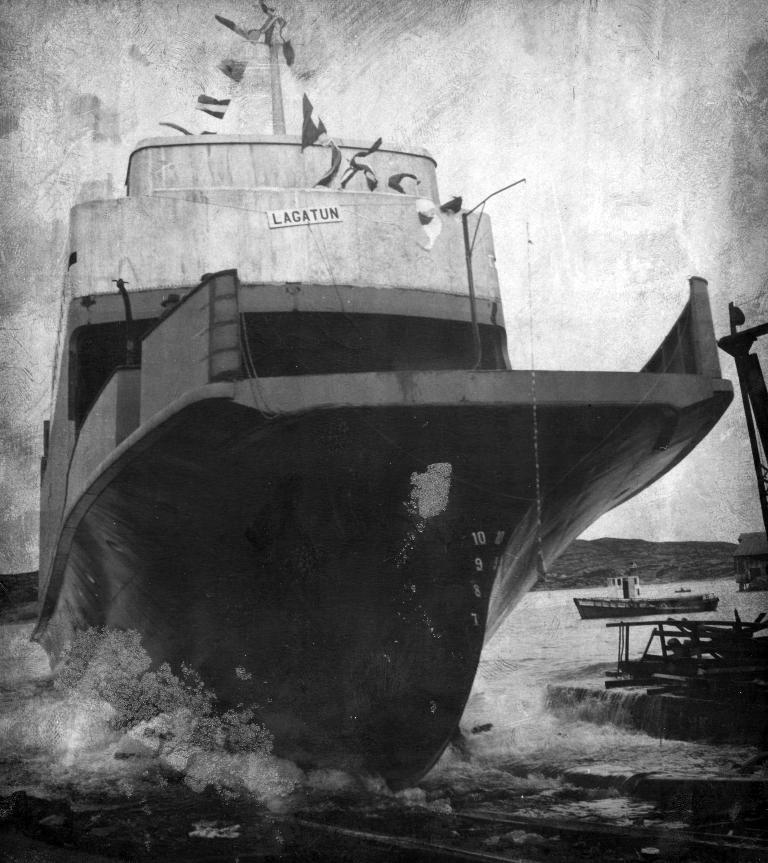What type of vehicle is in the image? There is a cargo ship in the image. Where is the cargo ship located? The cargo ship is on the water. What else can be seen on the right side of the image? There are other boards visible on the right side of the image. What is visible in the background of the image? There is a mountain in the background of the image. What is visible at the top of the image? The sky is visible at the top of the image. Where is the zoo located in the image? There is no zoo present in the image; it features a cargo ship on the water. What type of cattle can be seen grazing near the cargo ship in the image? There are no cattle present in the image; it features a cargo ship on the water. 